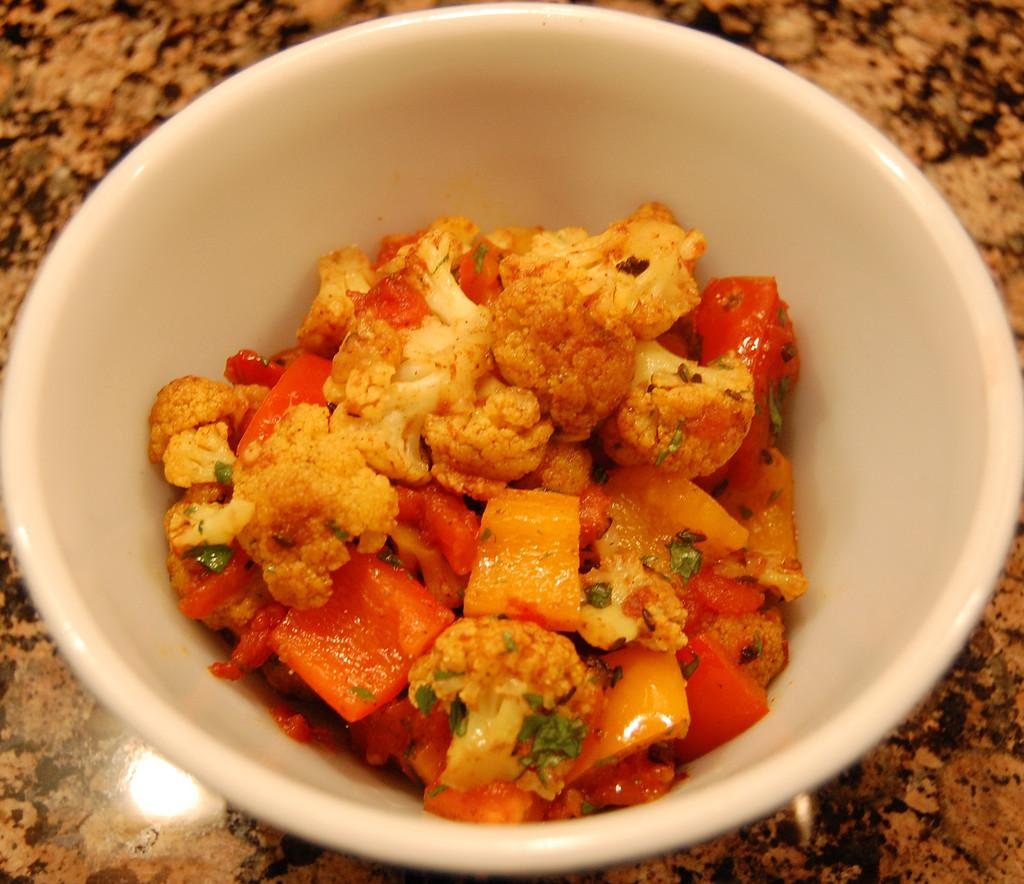What is the main subject of the image? There is a food item in the image. How is the food item contained or presented? The food item is in a bowl. Where is the bowl located? The bowl is on a platform. What type of underwear is visible in the image? There is no underwear present in the image. How does the food item attack the bowl in the image? The food item does not attack the bowl in the image; it is simply contained within it. 